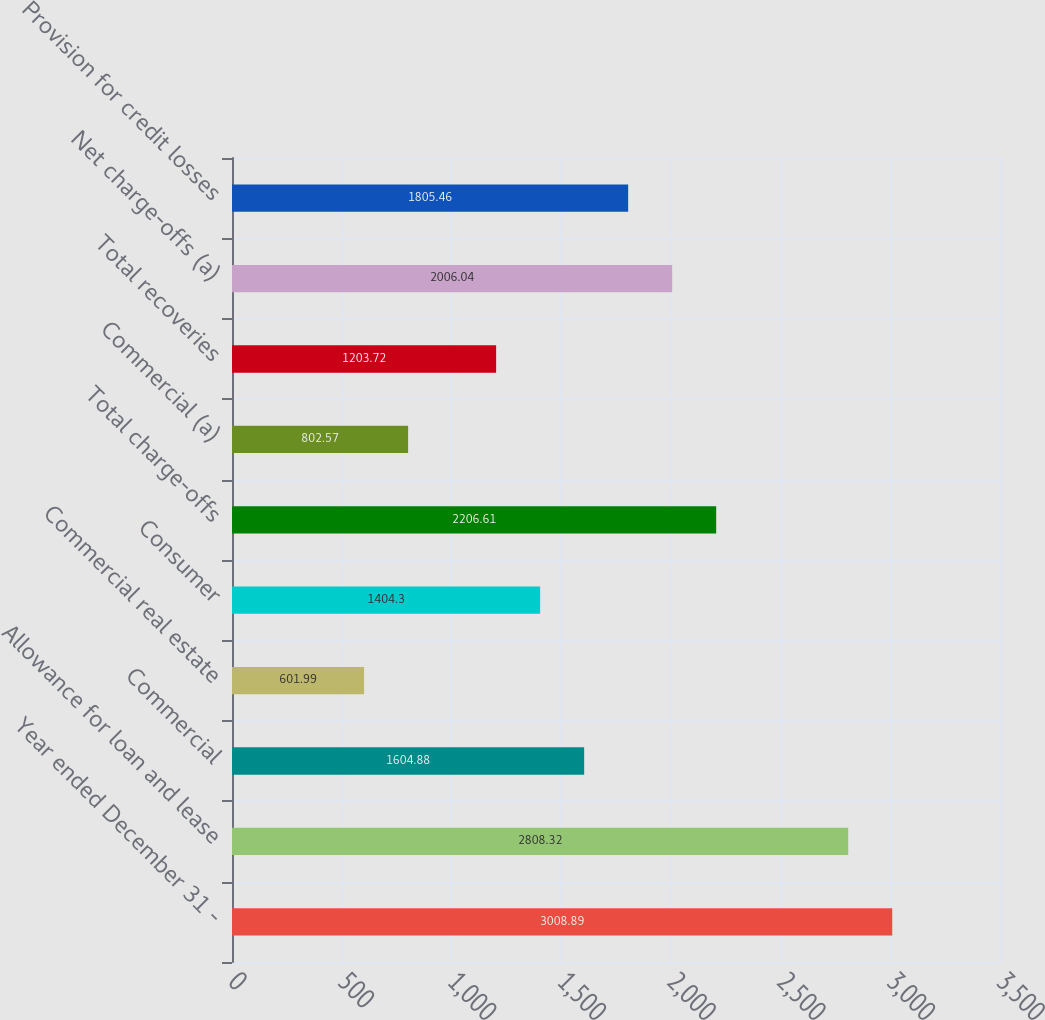Convert chart. <chart><loc_0><loc_0><loc_500><loc_500><bar_chart><fcel>Year ended December 31 -<fcel>Allowance for loan and lease<fcel>Commercial<fcel>Commercial real estate<fcel>Consumer<fcel>Total charge-offs<fcel>Commercial (a)<fcel>Total recoveries<fcel>Net charge-offs (a)<fcel>Provision for credit losses<nl><fcel>3008.89<fcel>2808.32<fcel>1604.88<fcel>601.99<fcel>1404.3<fcel>2206.61<fcel>802.57<fcel>1203.72<fcel>2006.04<fcel>1805.46<nl></chart> 